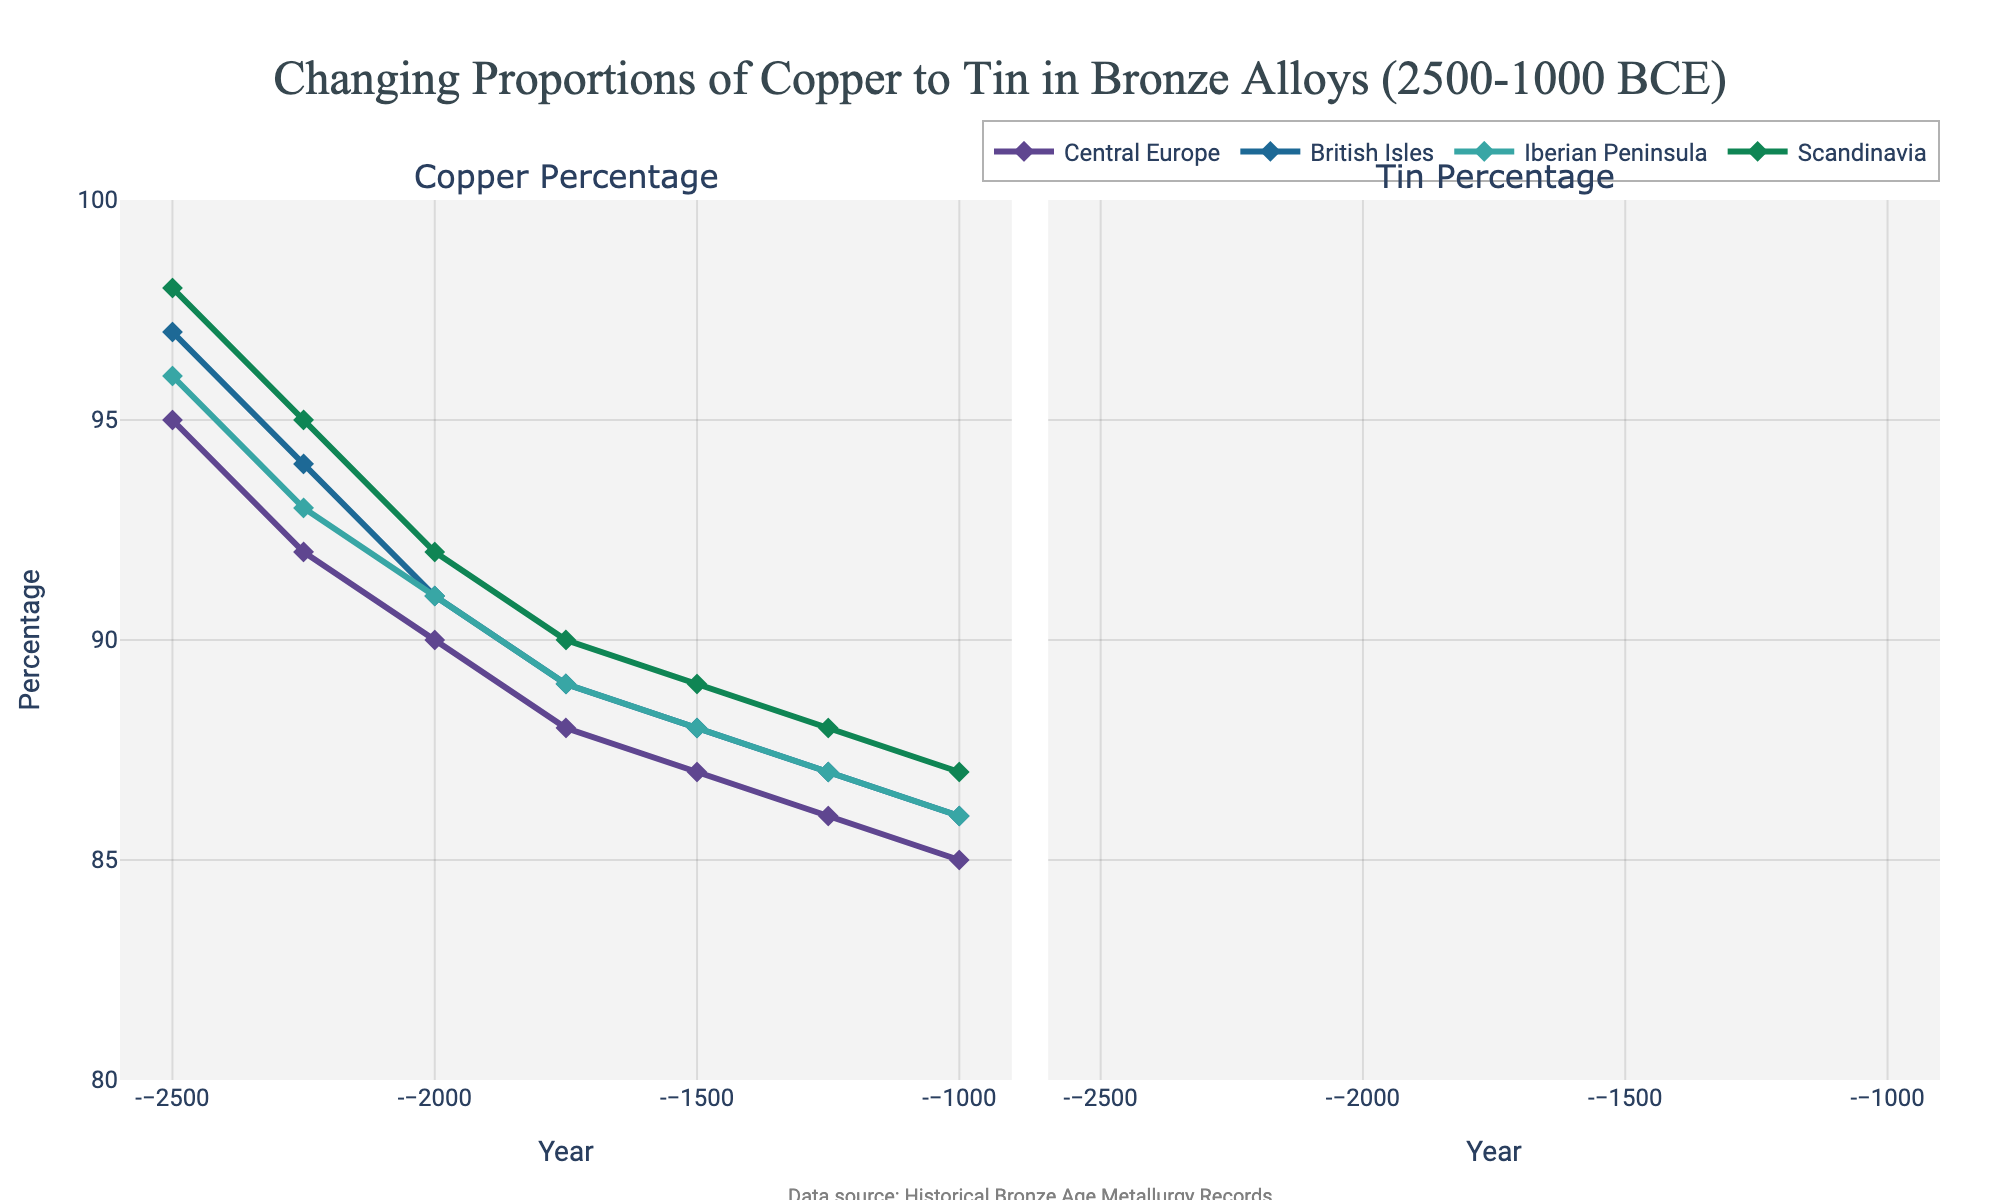Which region maintained the highest percentage of copper in its bronze alloys in 2500 BCE? In the Copper Percentage plot, observe the lines at 2500 BCE. Scandinavia shows the highest value at 98%.
Answer: Scandinavia Compare the change in copper percentage in Central Europe and the British Isles between 2500 BCE and 1000 BCE. Which region experienced a greater absolute change? Calculate the difference for each region: Central Europe (95 - 85) = 10%; British Isles (97 - 86) = 11%. Therefore, the British Isles experienced a greater change.
Answer: British Isles Between 2250 BCE and 1750 BCE, which region shows the greatest increase in tin percentage? Look at the slopes of the lines in the Tin Percentage plot. Central Europe increases from 8% to 12%, which is an increase of 4%, the highest in that period.
Answer: Central Europe What is the average copper percentage for the Iberian Peninsula from 2500 BCE to 2000 BCE? Sum the values: (96 + 93 + 91) = 280, then divide by 3. The average is 280 / 3 ≈ 93.33%.
Answer: 93.33% Identify the region with the smallest percentage difference between copper and tin in 1000 BCE and state that percentage difference. For each region in 1000 BCE, subtract the tin percentage from the copper percentage: Central Europe (85 - 15) = 70%; British Isles (86 - 14) = 72%; Iberian Peninsula (86 - 14) = 72%; Scandinavia (87 - 13) = 74%. The smallest difference is for Central Europe at 70%.
Answer: Central Europe, 70% Which region shows the most stable copper percentage over time, and what feature of the line indicates this? The line for any of the regions in the Copper Percentage plot can be compared by looking at consistency. Iberian Peninsula shows minimal variation, reflecting stability. This is indicated by the relatively flat line.
Answer: Iberian Peninsula How does the tin percentage in the British Isles in 1500 BCE compare to that in the Iberian Peninsula in the same year? Check the values at 1500 BCE in the Tin Percentage plot. Both the British Isles and the Iberian Peninsula have a tin percentage of 12%.
Answer: They are equal Determine the average increase per year in the tin percentage for Scandinavia from 2500 BCE to 1000 BCE. The total increase in tin percentage for Scandinavia is from 2% to 13%, a rise of 11%. Over 1500 years, this averages to 11% / 1500 ≈ 0.0073% per year.
Answer: Approximately 0.0073% per year Which region had the highest tin percentage in 2250 BCE, and what is that percentage? Look at the Tin Percentage plot and find the value for 2250 BCE. Central Europe had the highest tin percentage, which is 8%.
Answer: Central Europe, 8% 